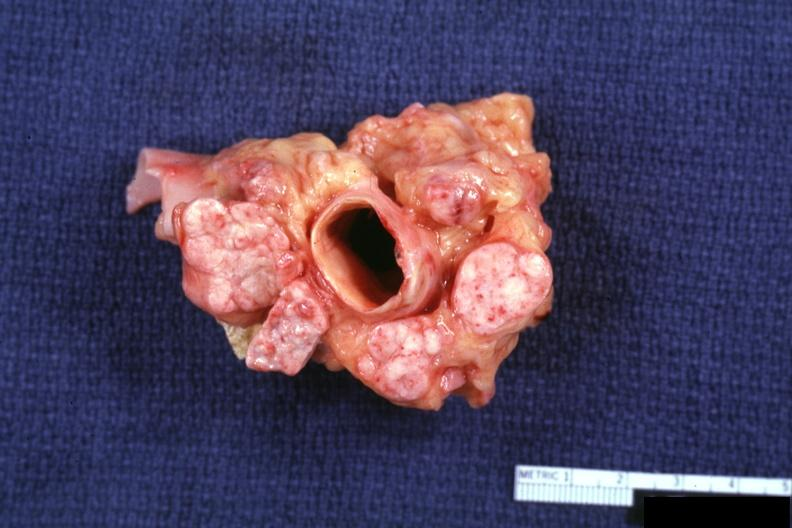what is present?
Answer the question using a single word or phrase. Lymph node 